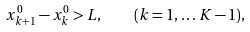Convert formula to latex. <formula><loc_0><loc_0><loc_500><loc_500>x _ { k + 1 } ^ { 0 } - x _ { k } ^ { 0 } > L , \quad ( k = 1 , \dots K - 1 ) ,</formula> 